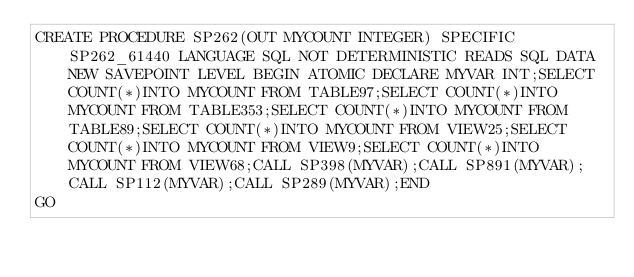Convert code to text. <code><loc_0><loc_0><loc_500><loc_500><_SQL_>CREATE PROCEDURE SP262(OUT MYCOUNT INTEGER) SPECIFIC SP262_61440 LANGUAGE SQL NOT DETERMINISTIC READS SQL DATA NEW SAVEPOINT LEVEL BEGIN ATOMIC DECLARE MYVAR INT;SELECT COUNT(*)INTO MYCOUNT FROM TABLE97;SELECT COUNT(*)INTO MYCOUNT FROM TABLE353;SELECT COUNT(*)INTO MYCOUNT FROM TABLE89;SELECT COUNT(*)INTO MYCOUNT FROM VIEW25;SELECT COUNT(*)INTO MYCOUNT FROM VIEW9;SELECT COUNT(*)INTO MYCOUNT FROM VIEW68;CALL SP398(MYVAR);CALL SP891(MYVAR);CALL SP112(MYVAR);CALL SP289(MYVAR);END
GO</code> 